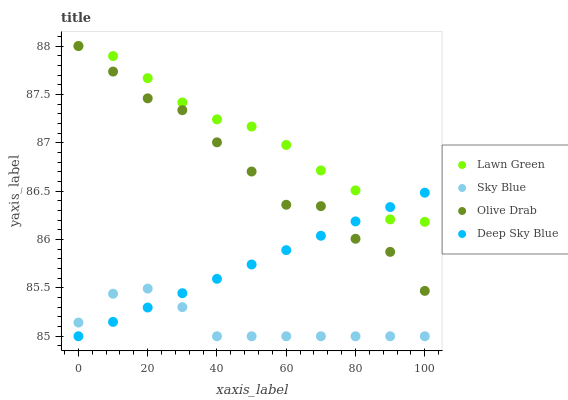Does Sky Blue have the minimum area under the curve?
Answer yes or no. Yes. Does Lawn Green have the maximum area under the curve?
Answer yes or no. Yes. Does Deep Sky Blue have the minimum area under the curve?
Answer yes or no. No. Does Deep Sky Blue have the maximum area under the curve?
Answer yes or no. No. Is Deep Sky Blue the smoothest?
Answer yes or no. Yes. Is Olive Drab the roughest?
Answer yes or no. Yes. Is Olive Drab the smoothest?
Answer yes or no. No. Is Deep Sky Blue the roughest?
Answer yes or no. No. Does Deep Sky Blue have the lowest value?
Answer yes or no. Yes. Does Olive Drab have the lowest value?
Answer yes or no. No. Does Olive Drab have the highest value?
Answer yes or no. Yes. Does Deep Sky Blue have the highest value?
Answer yes or no. No. Is Sky Blue less than Lawn Green?
Answer yes or no. Yes. Is Lawn Green greater than Sky Blue?
Answer yes or no. Yes. Does Olive Drab intersect Deep Sky Blue?
Answer yes or no. Yes. Is Olive Drab less than Deep Sky Blue?
Answer yes or no. No. Is Olive Drab greater than Deep Sky Blue?
Answer yes or no. No. Does Sky Blue intersect Lawn Green?
Answer yes or no. No. 